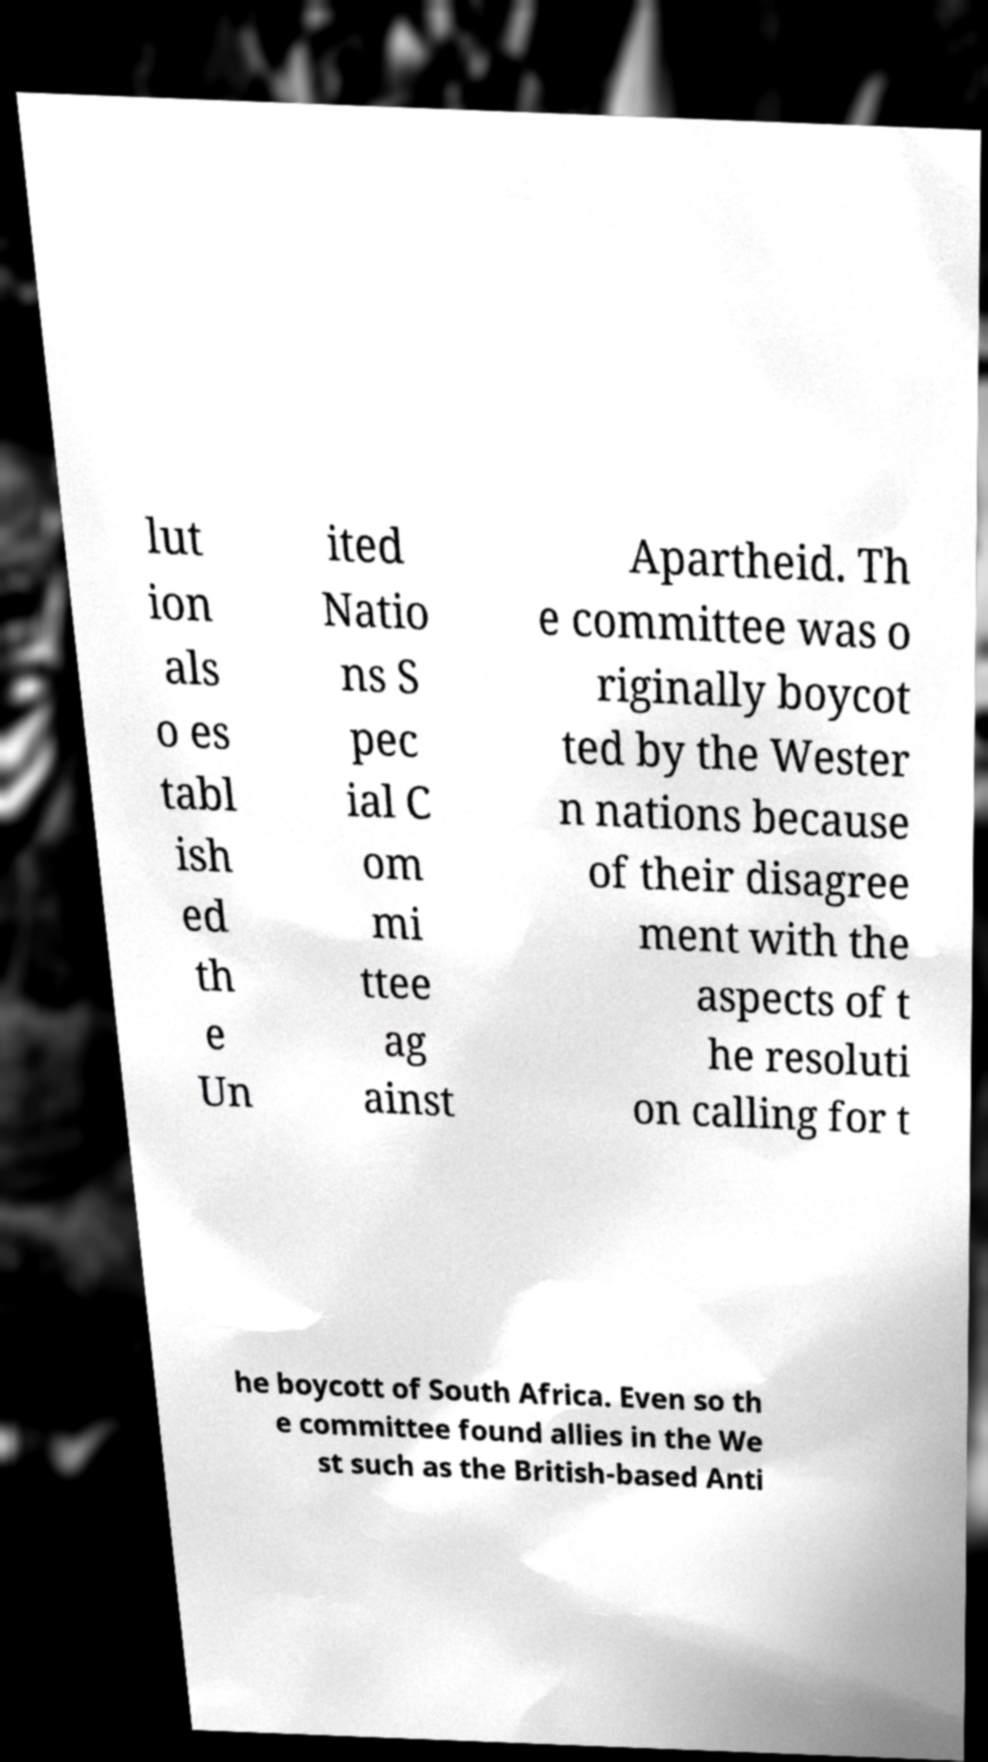Could you assist in decoding the text presented in this image and type it out clearly? lut ion als o es tabl ish ed th e Un ited Natio ns S pec ial C om mi ttee ag ainst Apartheid. Th e committee was o riginally boycot ted by the Wester n nations because of their disagree ment with the aspects of t he resoluti on calling for t he boycott of South Africa. Even so th e committee found allies in the We st such as the British-based Anti 